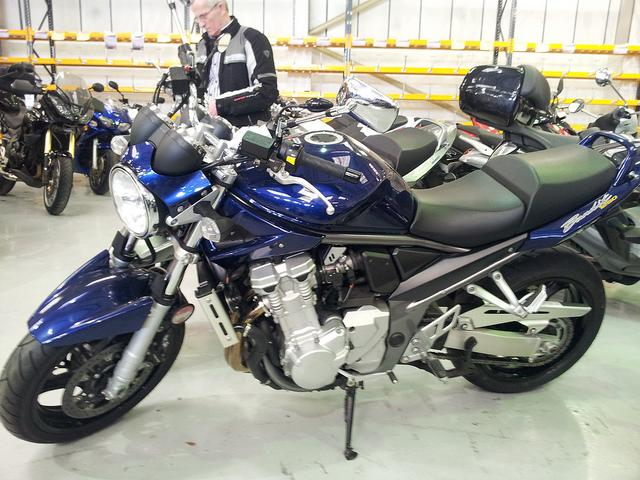What is he doing? viewing motorcycles 